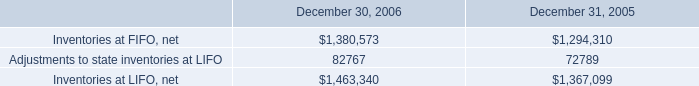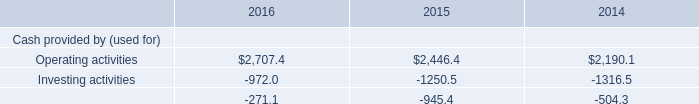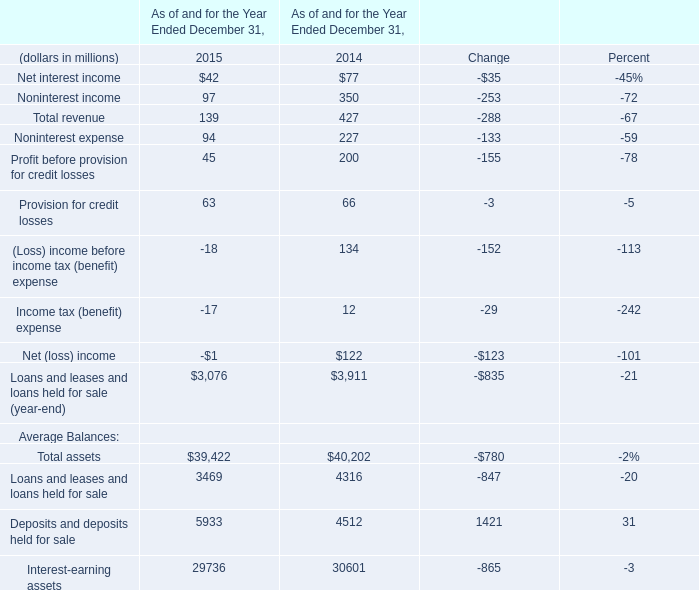What is the sum of Adjustments to state inventories at LIFO of December 31, 2005, and Operating activities of 2016 ? 
Computations: (72789.0 + 2707.4)
Answer: 75496.4. 